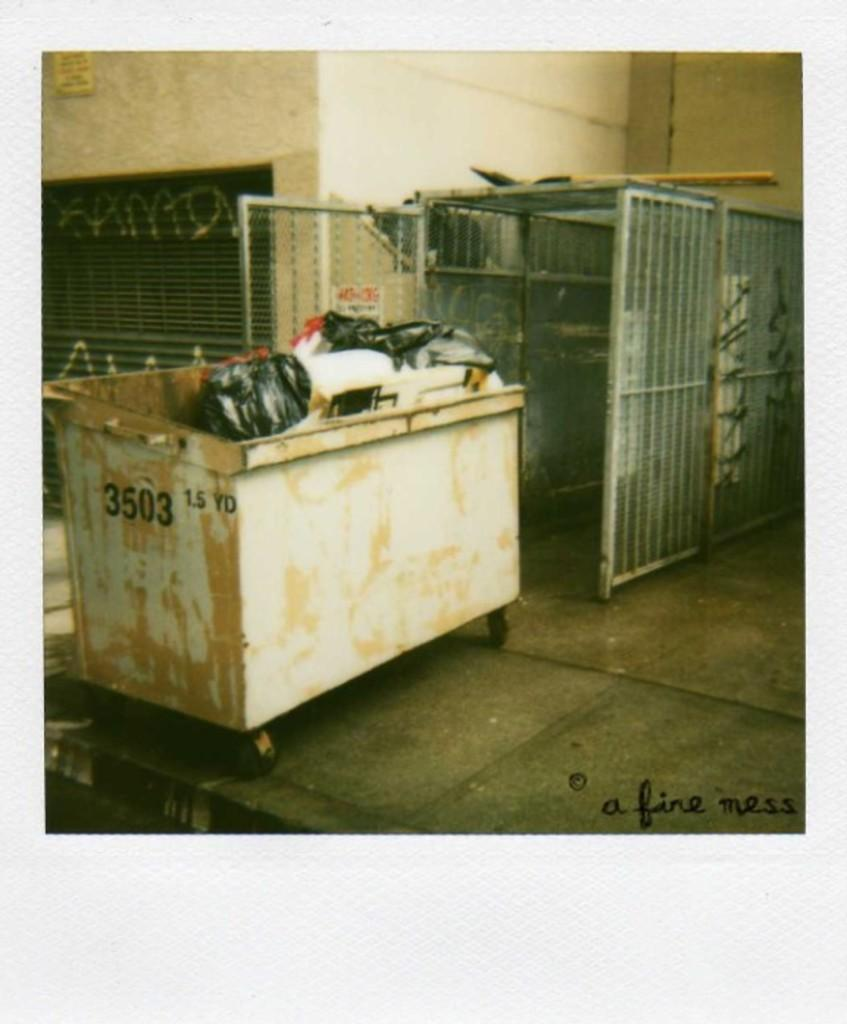<image>
Share a concise interpretation of the image provided. A dumpster is full and has the number 3503 on it. 